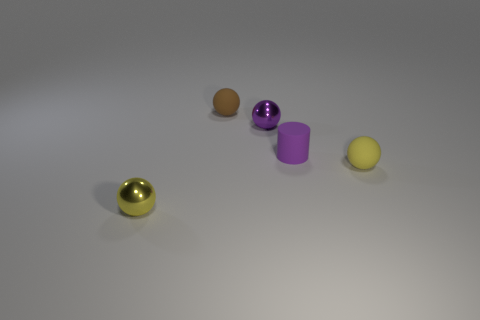Subtract 2 balls. How many balls are left? 2 Subtract all purple spheres. How many spheres are left? 3 Subtract all gray balls. Subtract all yellow cubes. How many balls are left? 4 Subtract all cylinders. How many objects are left? 4 Add 5 matte balls. How many objects exist? 10 Add 4 spheres. How many spheres are left? 8 Add 5 tiny rubber cylinders. How many tiny rubber cylinders exist? 6 Subtract 2 yellow balls. How many objects are left? 3 Subtract all tiny objects. Subtract all big yellow matte spheres. How many objects are left? 0 